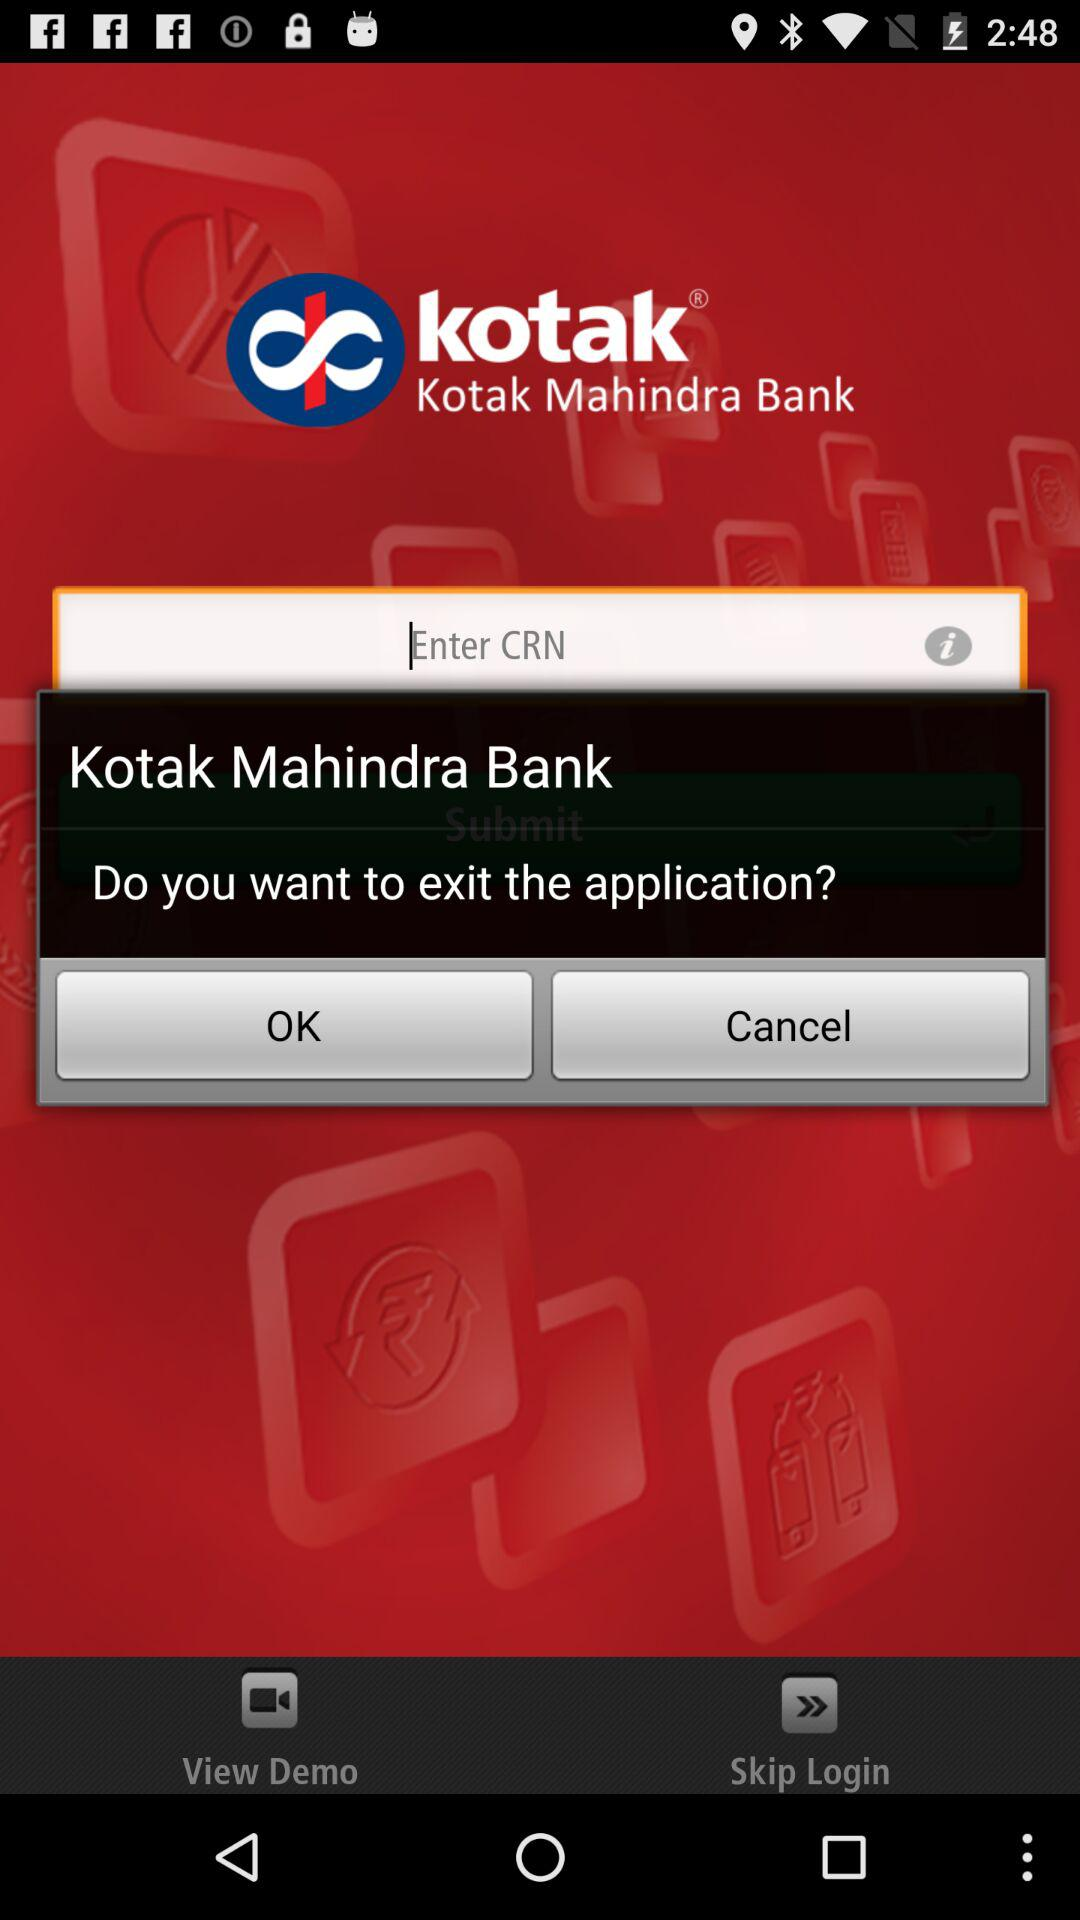How long is the demo video?
When the provided information is insufficient, respond with <no answer>. <no answer> 